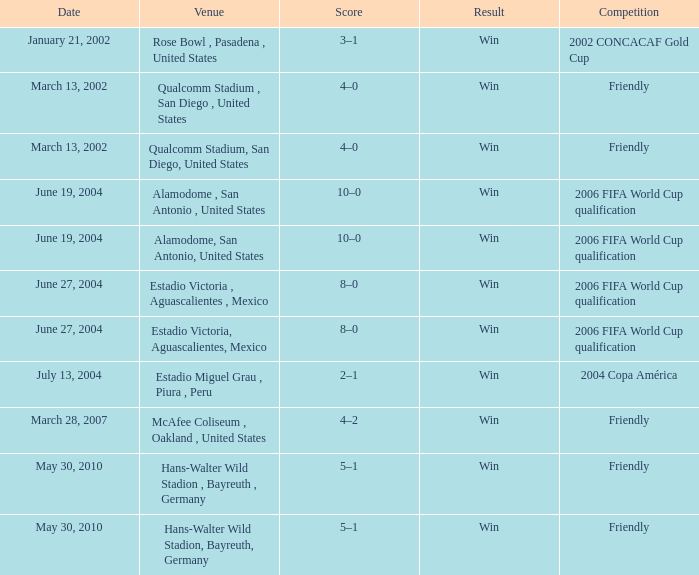On which date was the 2006 fifa world cup qualification held at alamodome, san antonio, united states? June 19, 2004, June 19, 2004. 